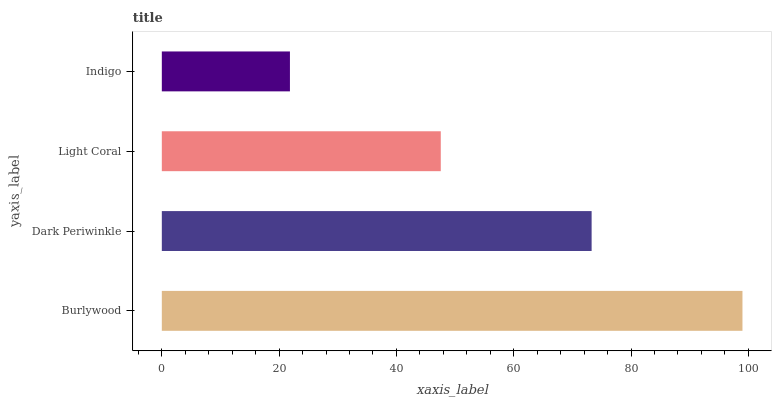Is Indigo the minimum?
Answer yes or no. Yes. Is Burlywood the maximum?
Answer yes or no. Yes. Is Dark Periwinkle the minimum?
Answer yes or no. No. Is Dark Periwinkle the maximum?
Answer yes or no. No. Is Burlywood greater than Dark Periwinkle?
Answer yes or no. Yes. Is Dark Periwinkle less than Burlywood?
Answer yes or no. Yes. Is Dark Periwinkle greater than Burlywood?
Answer yes or no. No. Is Burlywood less than Dark Periwinkle?
Answer yes or no. No. Is Dark Periwinkle the high median?
Answer yes or no. Yes. Is Light Coral the low median?
Answer yes or no. Yes. Is Burlywood the high median?
Answer yes or no. No. Is Burlywood the low median?
Answer yes or no. No. 